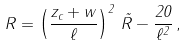<formula> <loc_0><loc_0><loc_500><loc_500>R = \left ( \frac { z _ { c } + w } { \ell } \right ) ^ { 2 } \, \tilde { R } - \frac { 2 0 } { \ell ^ { 2 } } \, ,</formula> 